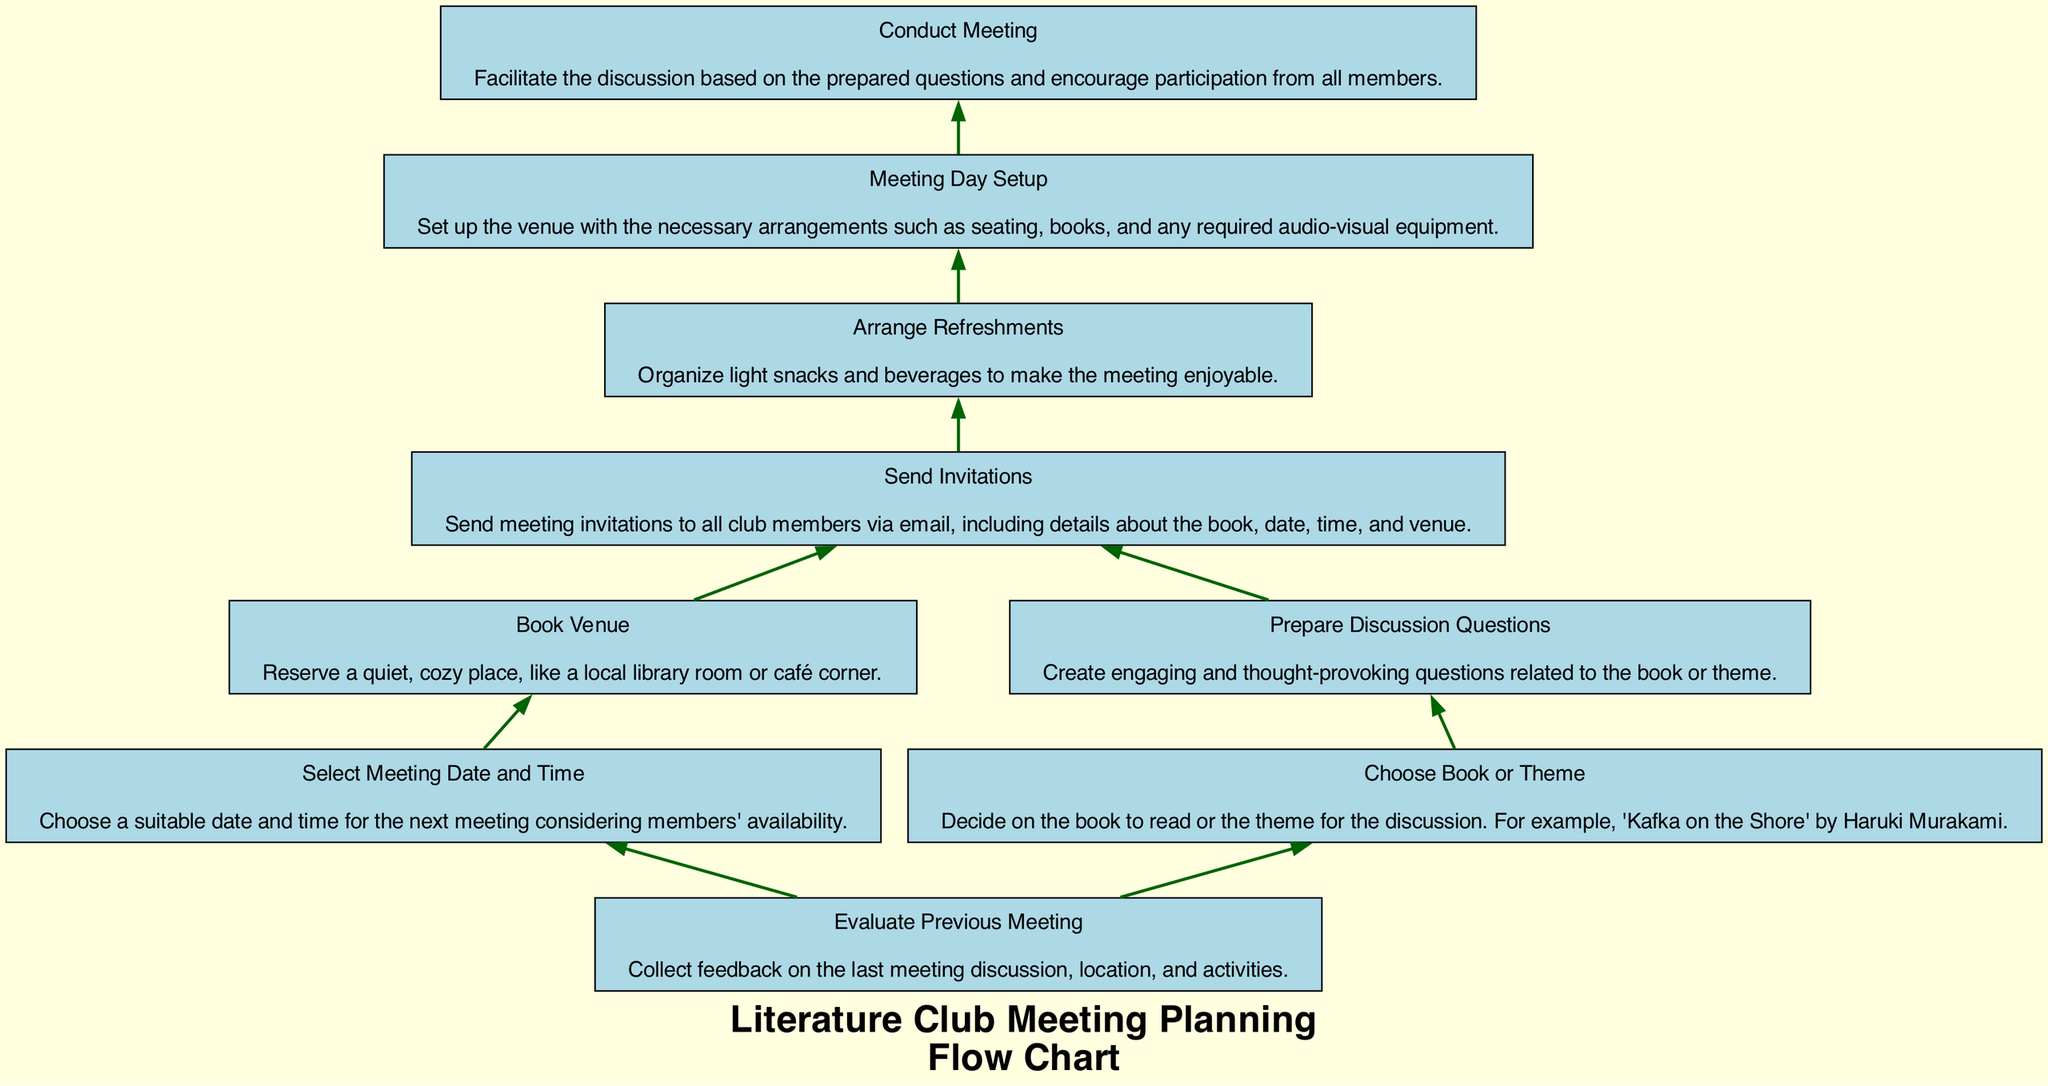What is the first step in planning a literature club meeting? The first step is "Evaluate Previous Meeting" which involves collecting feedback on previous discussions, locations, and activities.
Answer: Evaluate Previous Meeting How many nodes are there in the flow chart? By counting all the unique actions listed in the flow chart, we find there are a total of 9 nodes representing different steps in the meeting planning.
Answer: 9 What node follows "Choose Book or Theme"? After "Choose Book or Theme," the next step is "Prepare Discussion Questions," which is dependent on choosing the book or theme for the meeting.
Answer: Prepare Discussion Questions Which node is dependent on both "Book Venue" and "Prepare Discussion Questions"? The node that depends on both "Book Venue" and "Prepare Discussion Questions" is "Send Invitations," indicating that invitations should be sent after both the venue and discussion questions are arranged.
Answer: Send Invitations How many dependencies does "Conduct Meeting" have? The node "Conduct Meeting" has one dependency, which is "Meeting Day Setup," and this means conducting the meeting can only occur after the setup is complete.
Answer: 1 What is the last step in the flow chart? The final step in the diagram is "Conduct Meeting," indicating that all prior tasks must be fully completed before the meeting takes place.
Answer: Conduct Meeting Which step must be completed before "Arrange Refreshments"? "Send Invitations" is the necessary step to complete before proceeding to "Arrange Refreshments," ensuring members know about the meeting details first.
Answer: Send Invitations If the theme chosen is "Kafka on the Shore," what node comes next? After choosing the theme "Kafka on the Shore," the next step is "Prepare Discussion Questions," which is about creating engaging questions related to the selected theme.
Answer: Prepare Discussion Questions What type of venue is suggested for booking? The diagram suggests booking a "quiet, cozy place, like a local library room or café corner" for the meeting venue, adding comfort to the gathering.
Answer: quiet, cozy place, like a local library room or café corner 